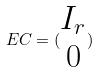<formula> <loc_0><loc_0><loc_500><loc_500>E C = ( \begin{matrix} I _ { r } \\ 0 \end{matrix} )</formula> 